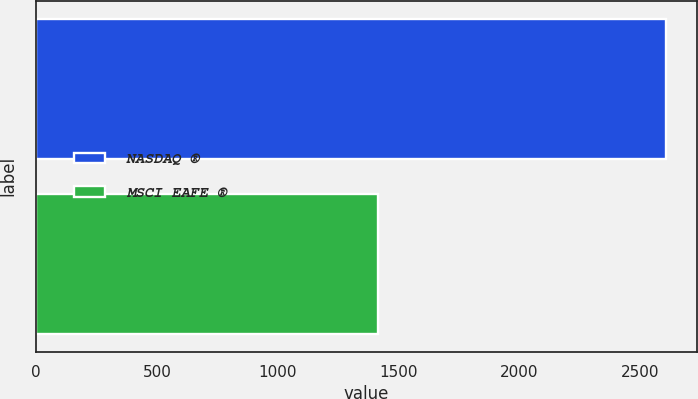Convert chart. <chart><loc_0><loc_0><loc_500><loc_500><bar_chart><fcel>NASDAQ ®<fcel>MSCI EAFE ®<nl><fcel>2605<fcel>1413<nl></chart> 